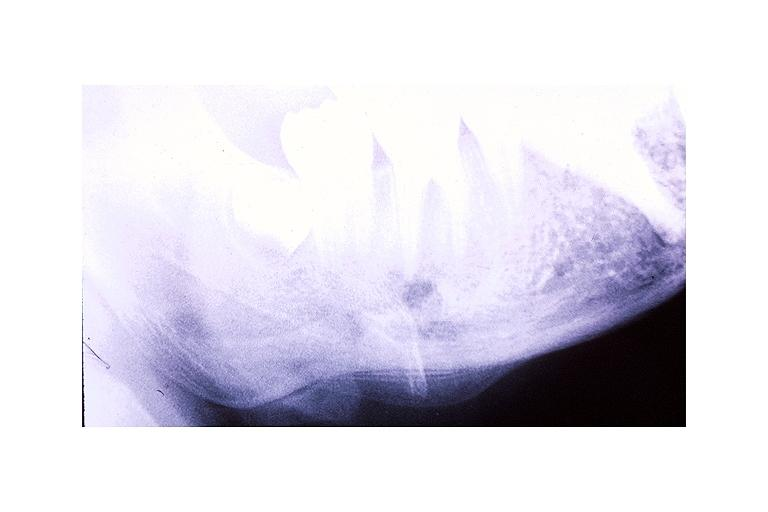what does this image show?
Answer the question using a single word or phrase. Garres osteomyelitis proliferative periosteitis 